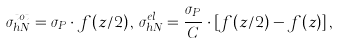<formula> <loc_0><loc_0><loc_500><loc_500>\sigma ^ { t o t } _ { h N } = \sigma _ { P } \cdot f ( z / 2 ) \, , \, \sigma ^ { e l } _ { h N } = \frac { \sigma _ { P } } { C } \cdot [ f ( z / 2 ) - f ( z ) ] \, ,</formula> 